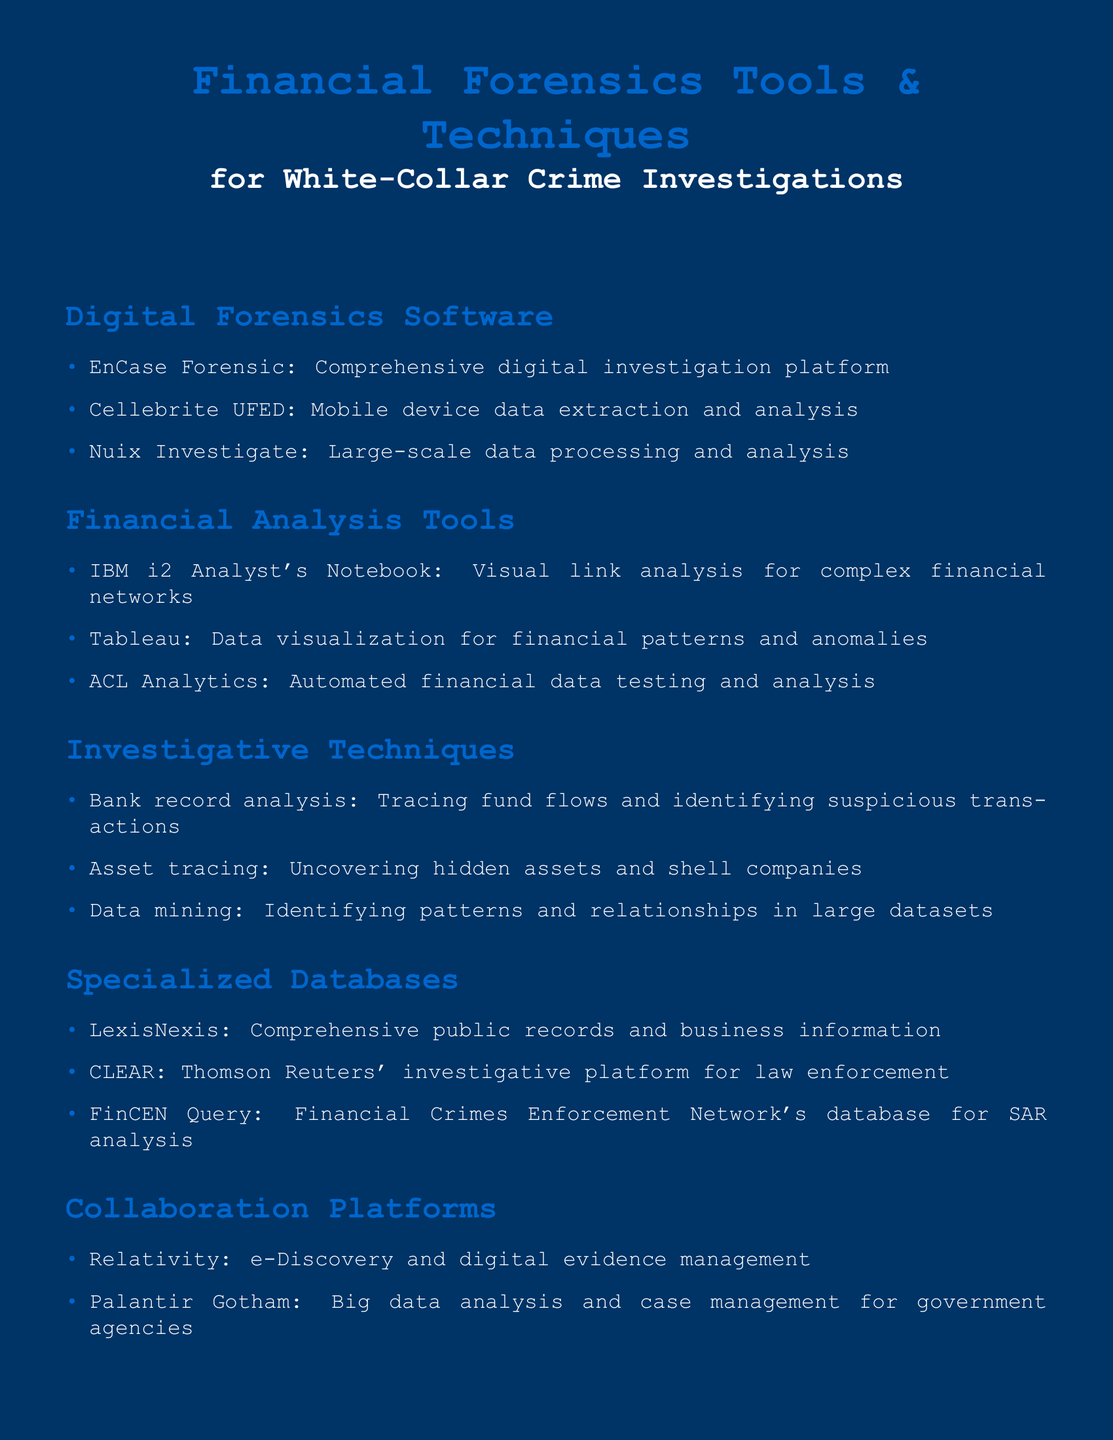What is the title of the document? The title of the document is prominently displayed at the top and summarizes the content, which is focused on financial forensics tools and techniques.
Answer: Financial Forensics Tools & Techniques for White-Collar Crime Investigations How many Digital Forensics Software tools are listed? The document lists three tools under the Digital Forensics Software section.
Answer: 3 What is the primary purpose of IBM i2 Analyst's Notebook? The purpose of this tool is described in the document, emphasizing visual link analysis for financial networks.
Answer: Visual link analysis Which specialized database is used for SAR analysis? The document specifies a database dedicated to analyzing Suspicious Activity Reports (SAR).
Answer: FinCEN Query Name a collaboration platform mentioned in the document. The document lists two specific platforms under the Collaboration Platforms section, and one is needed here.
Answer: Relativity What investigative technique is used to uncover hidden assets? One of the investigative techniques mentioned in the document focuses on revealing assets that may not be visible at first glance.
Answer: Asset tracing Which tool is used for mobile device data extraction? The document lists a specific tool for this purpose in the Digital Forensics Software section.
Answer: Cellebrite UFED What type of analysis does Tableau perform? The document details the function of Tableau as a financial data visualization tool.
Answer: Data visualization How many tools are listed under Financial Analysis Tools? The total number of tools in the Financial Analysis Tools section is noted in the document.
Answer: 3 